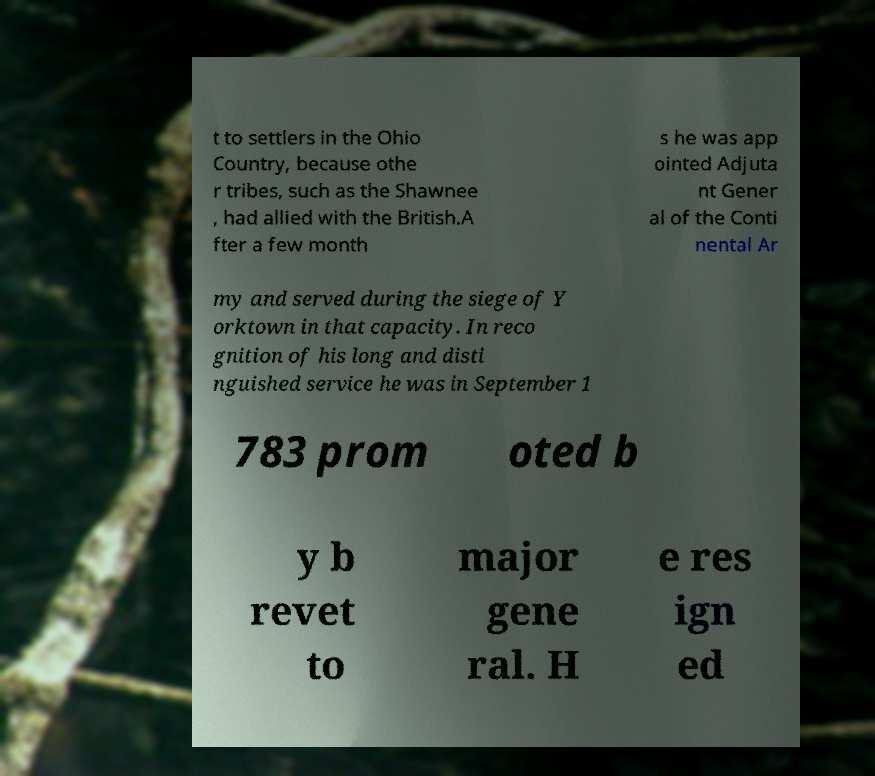Please read and relay the text visible in this image. What does it say? t to settlers in the Ohio Country, because othe r tribes, such as the Shawnee , had allied with the British.A fter a few month s he was app ointed Adjuta nt Gener al of the Conti nental Ar my and served during the siege of Y orktown in that capacity. In reco gnition of his long and disti nguished service he was in September 1 783 prom oted b y b revet to major gene ral. H e res ign ed 